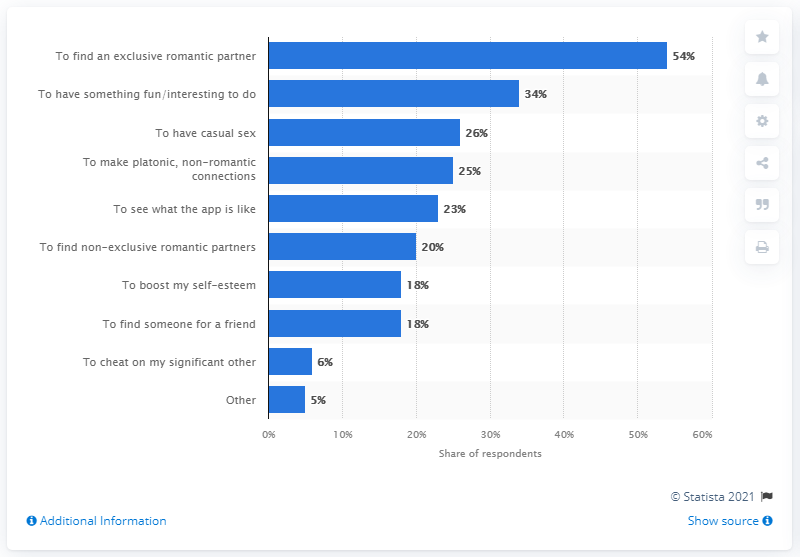Indicate a few pertinent items in this graphic. Thirty-four percent of users reported that they joined to have fun or to find interesting activities. According to data, 23% of users joined out of curiosity to see what the app was like. 